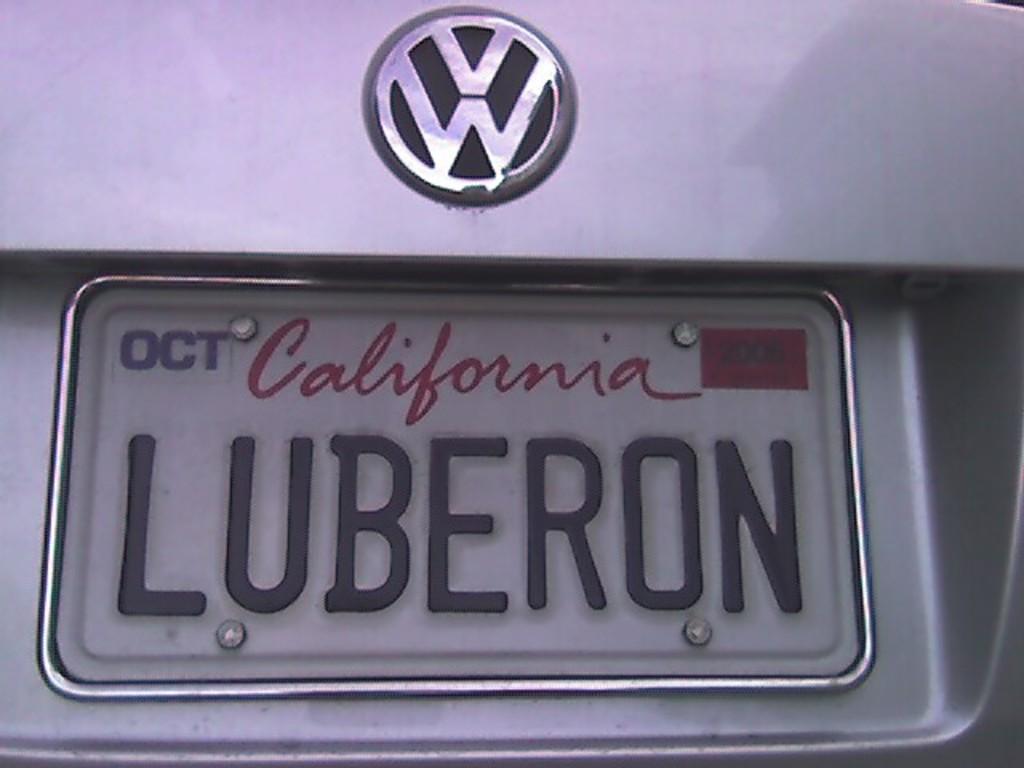What is the name of the license plate?
Offer a terse response. Luberon. What state is the license plate from?
Provide a short and direct response. California. 